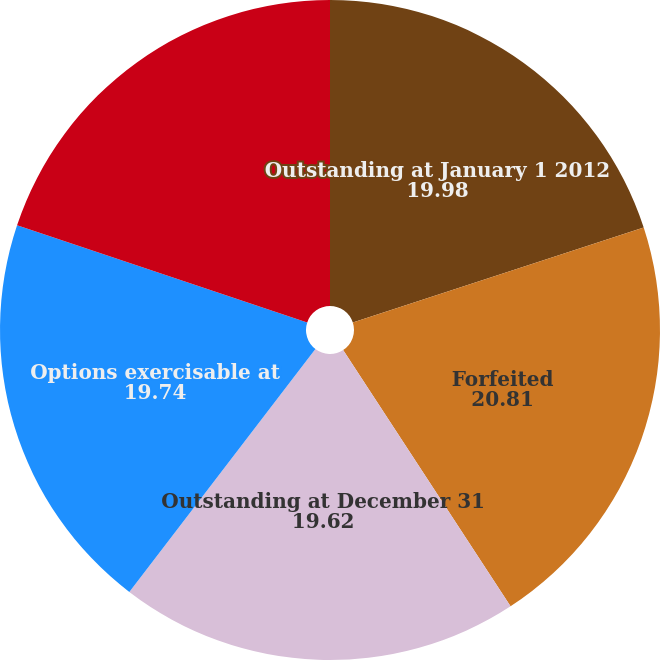Convert chart to OTSL. <chart><loc_0><loc_0><loc_500><loc_500><pie_chart><fcel>Outstanding at January 1 2012<fcel>Forfeited<fcel>Outstanding at December 31<fcel>Options exercisable at<fcel>Options vested and expected to<nl><fcel>19.98%<fcel>20.81%<fcel>19.62%<fcel>19.74%<fcel>19.86%<nl></chart> 